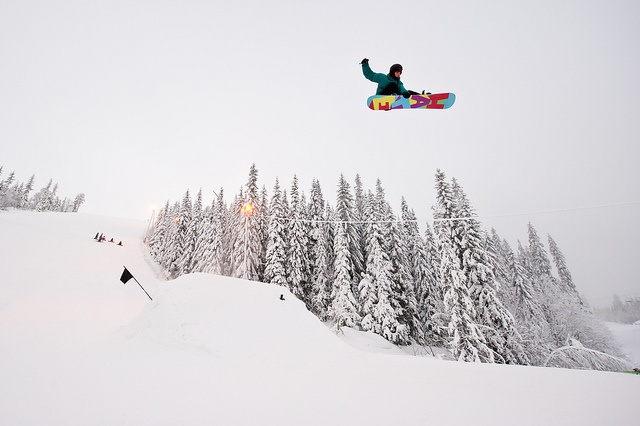Describe the objects in this image and their specific colors. I can see snowboard in lightgray, brown, lightblue, khaki, and purple tones, people in lightgray, black, teal, white, and darkblue tones, people in lightgray, gray, tan, and lavender tones, people in lightgray, black, gray, and darkgray tones, and people in lightgray, gray, and black tones in this image. 